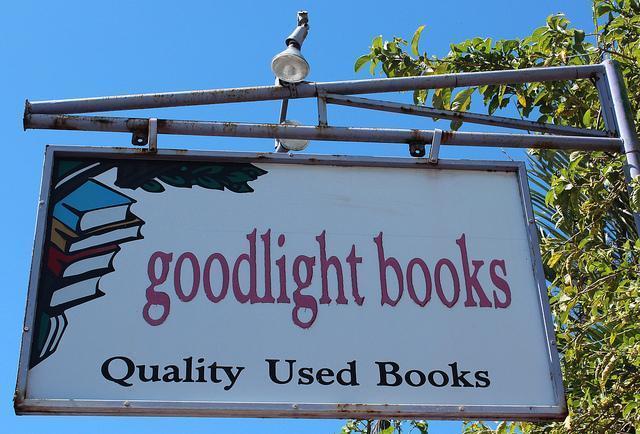How many books are on the sign?
Give a very brief answer. 4. How many books are in the photo?
Give a very brief answer. 3. 